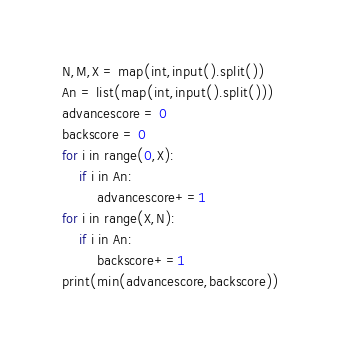<code> <loc_0><loc_0><loc_500><loc_500><_Python_>N,M,X = map(int,input().split())
An = list(map(int,input().split()))
advancescore = 0
backscore = 0
for i in range(0,X):
    if i in An:
        advancescore+=1
for i in range(X,N):
    if i in An:
        backscore+=1
print(min(advancescore,backscore))</code> 